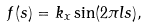<formula> <loc_0><loc_0><loc_500><loc_500>f ( s ) = k _ { x } \sin ( 2 \pi l s ) ,</formula> 